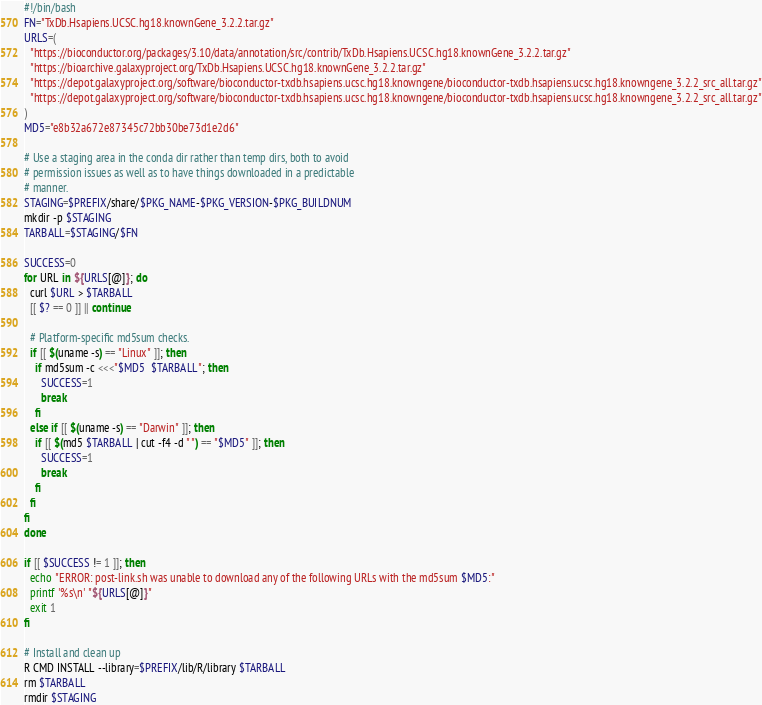<code> <loc_0><loc_0><loc_500><loc_500><_Bash_>#!/bin/bash
FN="TxDb.Hsapiens.UCSC.hg18.knownGene_3.2.2.tar.gz"
URLS=(
  "https://bioconductor.org/packages/3.10/data/annotation/src/contrib/TxDb.Hsapiens.UCSC.hg18.knownGene_3.2.2.tar.gz"
  "https://bioarchive.galaxyproject.org/TxDb.Hsapiens.UCSC.hg18.knownGene_3.2.2.tar.gz"
  "https://depot.galaxyproject.org/software/bioconductor-txdb.hsapiens.ucsc.hg18.knowngene/bioconductor-txdb.hsapiens.ucsc.hg18.knowngene_3.2.2_src_all.tar.gz"
  "https://depot.galaxyproject.org/software/bioconductor-txdb.hsapiens.ucsc.hg18.knowngene/bioconductor-txdb.hsapiens.ucsc.hg18.knowngene_3.2.2_src_all.tar.gz"
)
MD5="e8b32a672e87345c72bb30be73d1e2d6"

# Use a staging area in the conda dir rather than temp dirs, both to avoid
# permission issues as well as to have things downloaded in a predictable
# manner.
STAGING=$PREFIX/share/$PKG_NAME-$PKG_VERSION-$PKG_BUILDNUM
mkdir -p $STAGING
TARBALL=$STAGING/$FN

SUCCESS=0
for URL in ${URLS[@]}; do
  curl $URL > $TARBALL
  [[ $? == 0 ]] || continue

  # Platform-specific md5sum checks.
  if [[ $(uname -s) == "Linux" ]]; then
    if md5sum -c <<<"$MD5  $TARBALL"; then
      SUCCESS=1
      break
    fi
  else if [[ $(uname -s) == "Darwin" ]]; then
    if [[ $(md5 $TARBALL | cut -f4 -d " ") == "$MD5" ]]; then
      SUCCESS=1
      break
    fi
  fi
fi
done

if [[ $SUCCESS != 1 ]]; then
  echo "ERROR: post-link.sh was unable to download any of the following URLs with the md5sum $MD5:"
  printf '%s\n' "${URLS[@]}"
  exit 1
fi

# Install and clean up
R CMD INSTALL --library=$PREFIX/lib/R/library $TARBALL
rm $TARBALL
rmdir $STAGING
</code> 